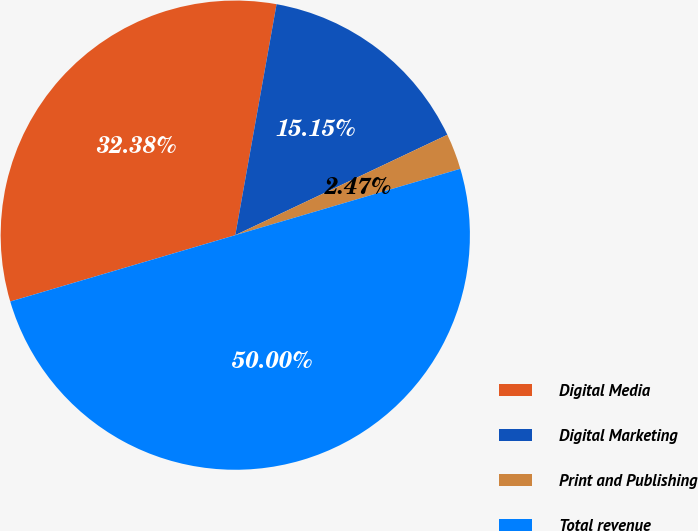Convert chart. <chart><loc_0><loc_0><loc_500><loc_500><pie_chart><fcel>Digital Media<fcel>Digital Marketing<fcel>Print and Publishing<fcel>Total revenue<nl><fcel>32.38%<fcel>15.15%<fcel>2.47%<fcel>50.0%<nl></chart> 